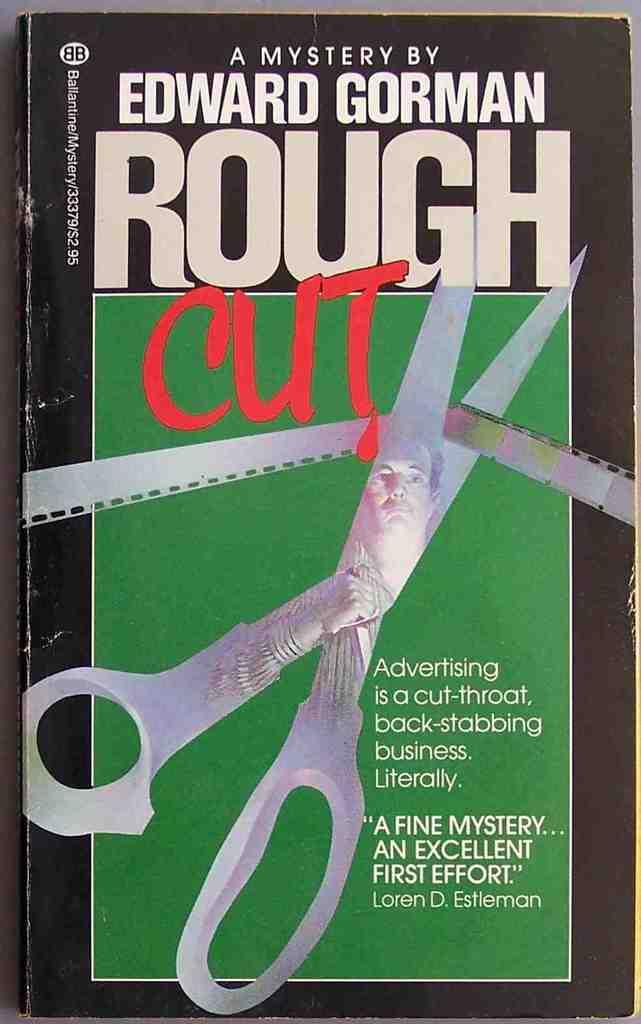What's the title of this?
Your answer should be very brief. Rough cut. Who wrote this book?
Your response must be concise. Edward gorman. 